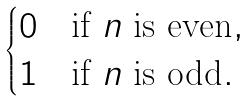<formula> <loc_0><loc_0><loc_500><loc_500>\begin{cases} 0 & \text {if $n$ is even} , \\ 1 & \text {if $n$ is odd} . \end{cases}</formula> 